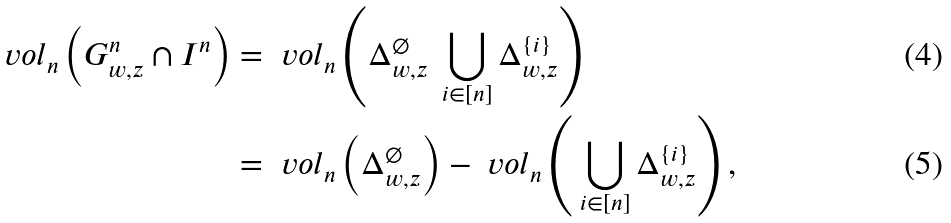Convert formula to latex. <formula><loc_0><loc_0><loc_500><loc_500>\ v o l _ { n } \left ( G _ { w , z } ^ { n } \cap I ^ { n } \right ) & = \ v o l _ { n } \left ( \Delta _ { w , z } ^ { \varnothing } \ \bigcup _ { i \in [ n ] } \Delta _ { w , z } ^ { \{ i \} } \right ) \\ & = \ v o l _ { n } \left ( \Delta _ { w , z } ^ { \varnothing } \right ) - \ v o l _ { n } \left ( \, \bigcup _ { i \in [ n ] } \Delta _ { w , z } ^ { \{ i \} } \right ) ,</formula> 